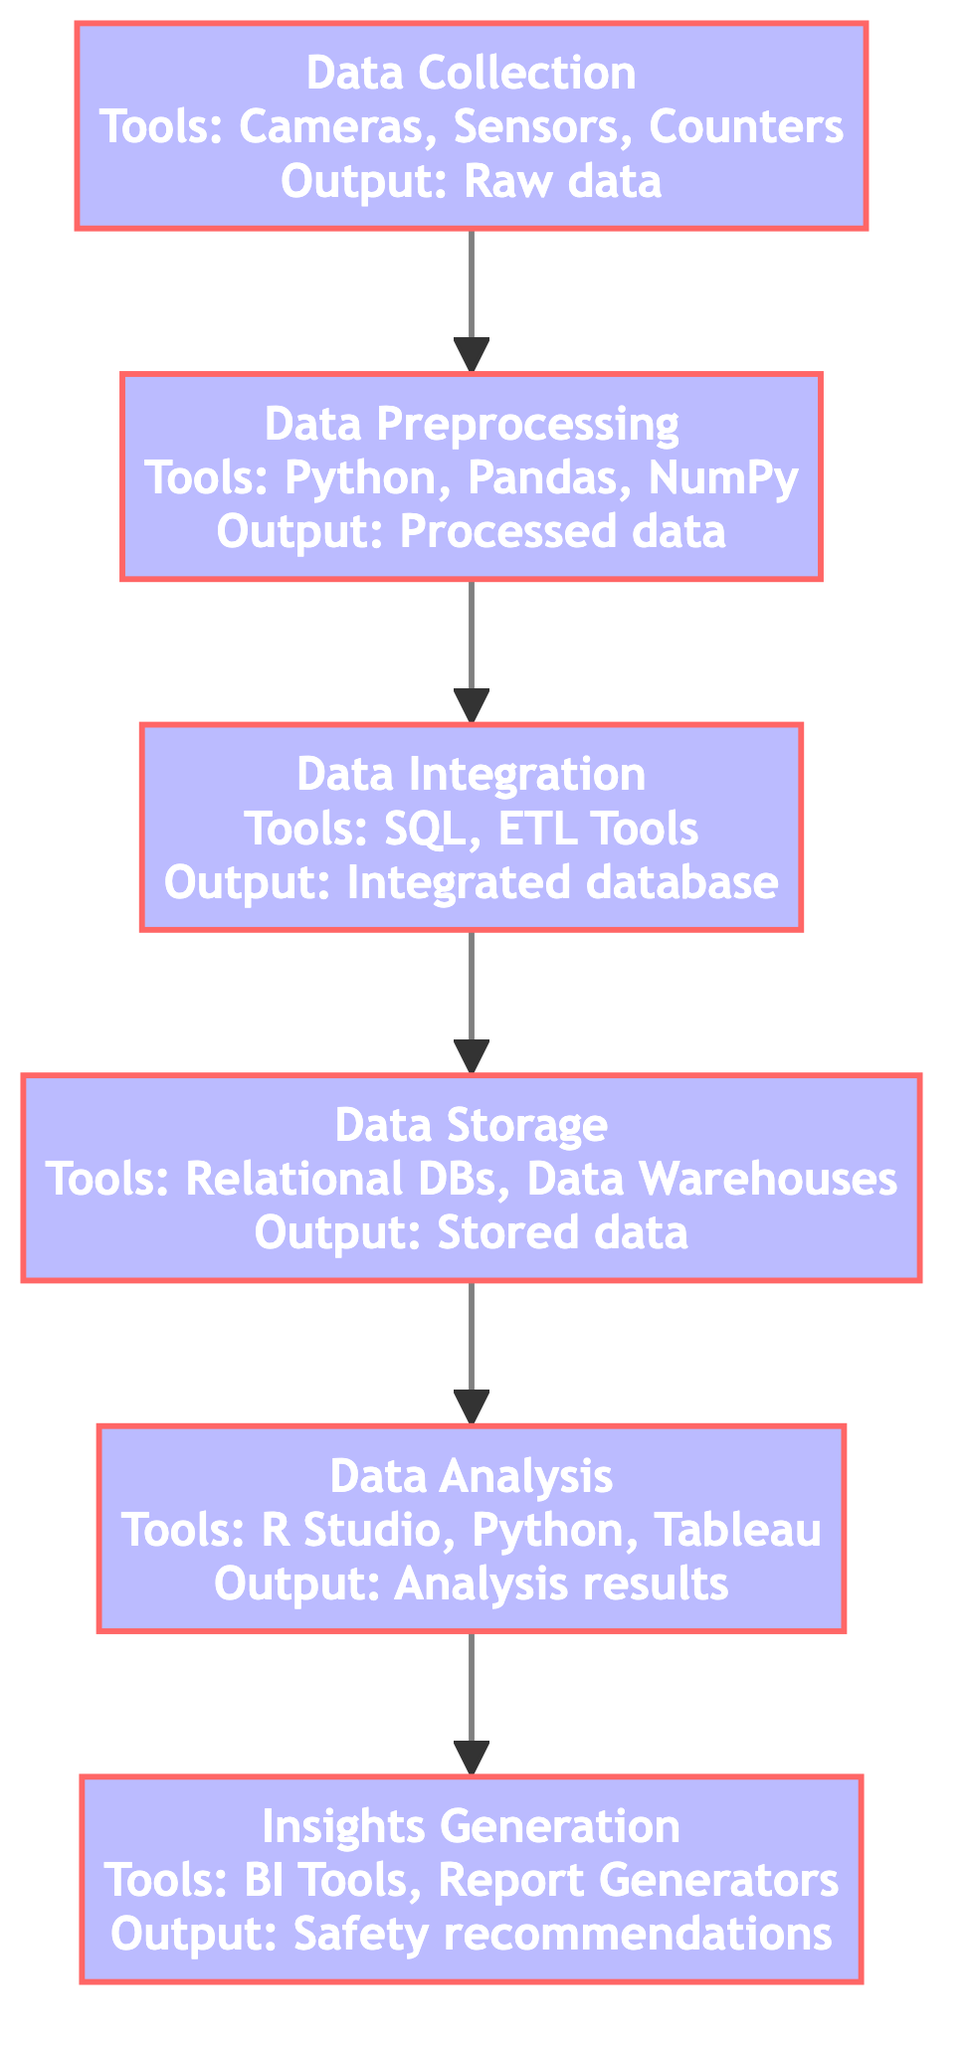What's the output of the Data Collection step? The Data Collection step produces "Raw pedestrian traffic data" as its output. This is directly stated in the diagram under the Data Collection node.
Answer: Raw pedestrian traffic data How many processes are involved in the analysis of pedestrian traffic data? The diagram outlines six processes: Data Collection, Data Preprocessing, Data Integration, Data Storage, Data Analysis, and Insights Generation. Thus, the total number is counted from the nodes presented.
Answer: Six What tools are used in the Data Preprocessing step? The Data Preprocessing step utilizes Python, Pandas, and NumPy as tools as listed in the respective node.
Answer: Python, Pandas, NumPy What is the first step in the analysis process? The first step in the process as shown in the diagram is Data Collection, positioned at the bottom of the flowchart.
Answer: Data Collection What is the relationship between Data Integration and Data Storage? Data Integration precedes Data Storage, meaning that the output from Data Integration, which is the "Integrated pedestrian traffic database," is used as the input for the Data Storage step. This can be traced through the flow of the diagram.
Answer: Data Integration leads to Data Storage What output follows the Data Analysis step? The output that follows the Data Analysis step is "Analysis results," which is noted at the Data Analysis node before moving to the Insights Generation node.
Answer: Analysis results Which step generates safety recommendations? The step named Insights Generation is responsible for generating safety recommendations based on the analysis results from the previous step. This is a direct interpretation of the output listed in that node.
Answer: Insights Generation What is the common tool used in both Data Analysis and Insights Generation? The common tool which is used in Data Analysis and Insights Generation is "Business Intelligence Tools." This can be verified by looking at the tools listed for each of those nodes in the diagram.
Answer: Business Intelligence Tools What is the role of ETL Tools in the analysis process? ETL Tools are used in the Data Integration step to combine data from multiple sources into a unified dataset, as indicated in the diagram under the Data Integration node.
Answer: Combine data sources 